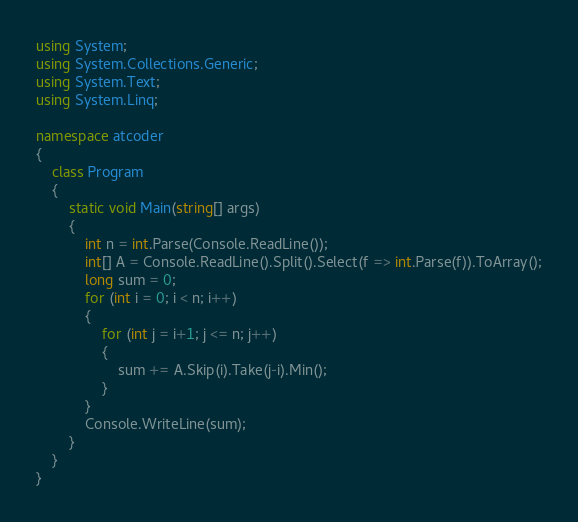Convert code to text. <code><loc_0><loc_0><loc_500><loc_500><_C#_>using System;
using System.Collections.Generic;
using System.Text;
using System.Linq;

namespace atcoder
{
    class Program
    {
        static void Main(string[] args)
        {
            int n = int.Parse(Console.ReadLine());
            int[] A = Console.ReadLine().Split().Select(f => int.Parse(f)).ToArray();
            long sum = 0;
            for (int i = 0; i < n; i++)
            {
                for (int j = i+1; j <= n; j++)
                {
                    sum += A.Skip(i).Take(j-i).Min();
                }
            }
            Console.WriteLine(sum);
        }
    }
}
</code> 